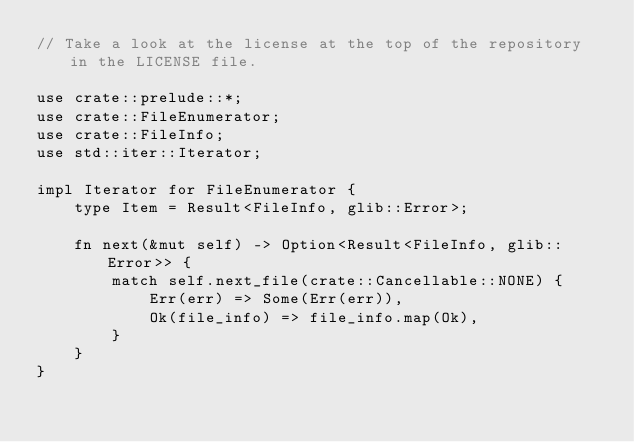<code> <loc_0><loc_0><loc_500><loc_500><_Rust_>// Take a look at the license at the top of the repository in the LICENSE file.

use crate::prelude::*;
use crate::FileEnumerator;
use crate::FileInfo;
use std::iter::Iterator;

impl Iterator for FileEnumerator {
    type Item = Result<FileInfo, glib::Error>;

    fn next(&mut self) -> Option<Result<FileInfo, glib::Error>> {
        match self.next_file(crate::Cancellable::NONE) {
            Err(err) => Some(Err(err)),
            Ok(file_info) => file_info.map(Ok),
        }
    }
}
</code> 